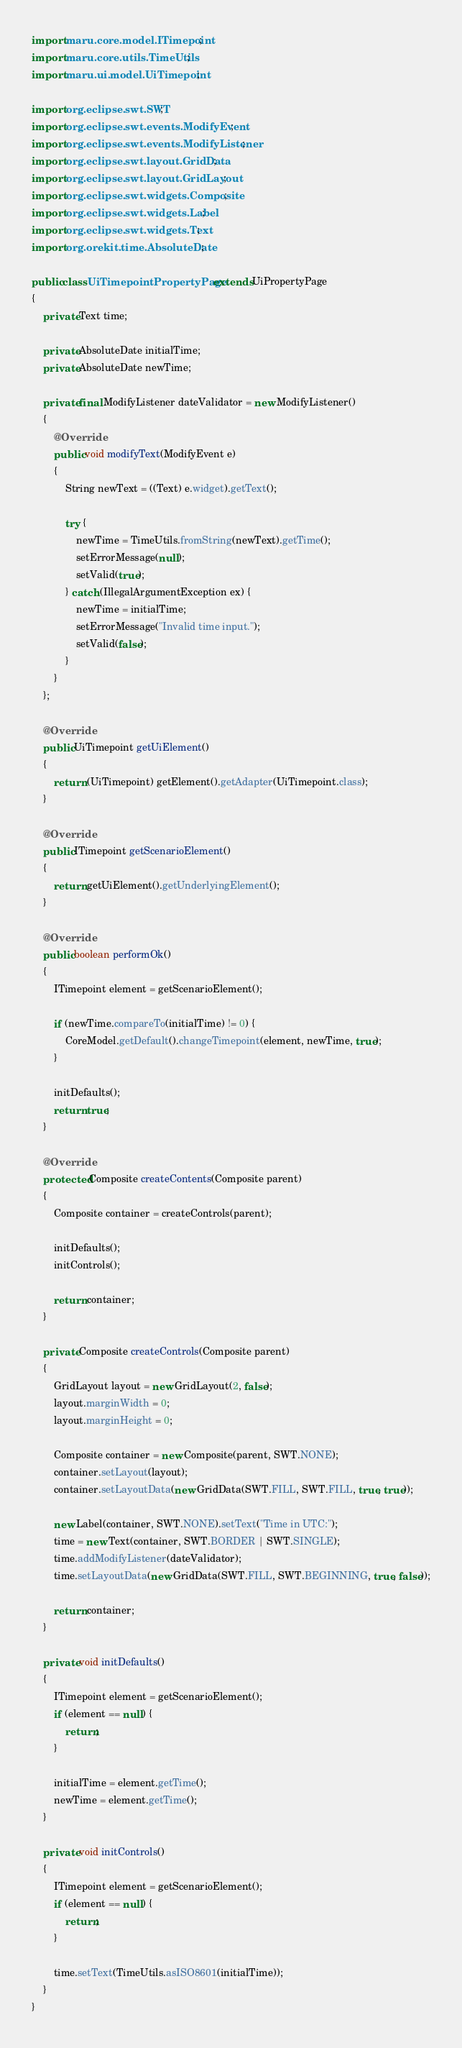<code> <loc_0><loc_0><loc_500><loc_500><_Java_>import maru.core.model.ITimepoint;
import maru.core.utils.TimeUtils;
import maru.ui.model.UiTimepoint;

import org.eclipse.swt.SWT;
import org.eclipse.swt.events.ModifyEvent;
import org.eclipse.swt.events.ModifyListener;
import org.eclipse.swt.layout.GridData;
import org.eclipse.swt.layout.GridLayout;
import org.eclipse.swt.widgets.Composite;
import org.eclipse.swt.widgets.Label;
import org.eclipse.swt.widgets.Text;
import org.orekit.time.AbsoluteDate;

public class UiTimepointPropertyPage extends UiPropertyPage
{
    private Text time;

    private AbsoluteDate initialTime;
    private AbsoluteDate newTime;

    private final ModifyListener dateValidator = new ModifyListener()
    {
        @Override
        public void modifyText(ModifyEvent e)
        {
            String newText = ((Text) e.widget).getText();

            try {
                newTime = TimeUtils.fromString(newText).getTime();
                setErrorMessage(null);
                setValid(true);
            } catch (IllegalArgumentException ex) {
                newTime = initialTime;
                setErrorMessage("Invalid time input.");
                setValid(false);
            }
        }
    };

    @Override
    public UiTimepoint getUiElement()
    {
        return (UiTimepoint) getElement().getAdapter(UiTimepoint.class);
    }

    @Override
    public ITimepoint getScenarioElement()
    {
        return getUiElement().getUnderlyingElement();
    }

    @Override
    public boolean performOk()
    {
        ITimepoint element = getScenarioElement();

        if (newTime.compareTo(initialTime) != 0) {
            CoreModel.getDefault().changeTimepoint(element, newTime, true);
        }

        initDefaults();
        return true;
    }

    @Override
    protected Composite createContents(Composite parent)
    {
        Composite container = createControls(parent);

        initDefaults();
        initControls();

        return container;
    }

    private Composite createControls(Composite parent)
    {
        GridLayout layout = new GridLayout(2, false);
        layout.marginWidth = 0;
        layout.marginHeight = 0;

        Composite container = new Composite(parent, SWT.NONE);
        container.setLayout(layout);
        container.setLayoutData(new GridData(SWT.FILL, SWT.FILL, true, true));

        new Label(container, SWT.NONE).setText("Time in UTC:");
        time = new Text(container, SWT.BORDER | SWT.SINGLE);
        time.addModifyListener(dateValidator);
        time.setLayoutData(new GridData(SWT.FILL, SWT.BEGINNING, true, false));

        return container;
    }

    private void initDefaults()
    {
        ITimepoint element = getScenarioElement();
        if (element == null) {
            return;
        }

        initialTime = element.getTime();
        newTime = element.getTime();
    }

    private void initControls()
    {
        ITimepoint element = getScenarioElement();
        if (element == null) {
            return;
        }

        time.setText(TimeUtils.asISO8601(initialTime));
    }
}
</code> 